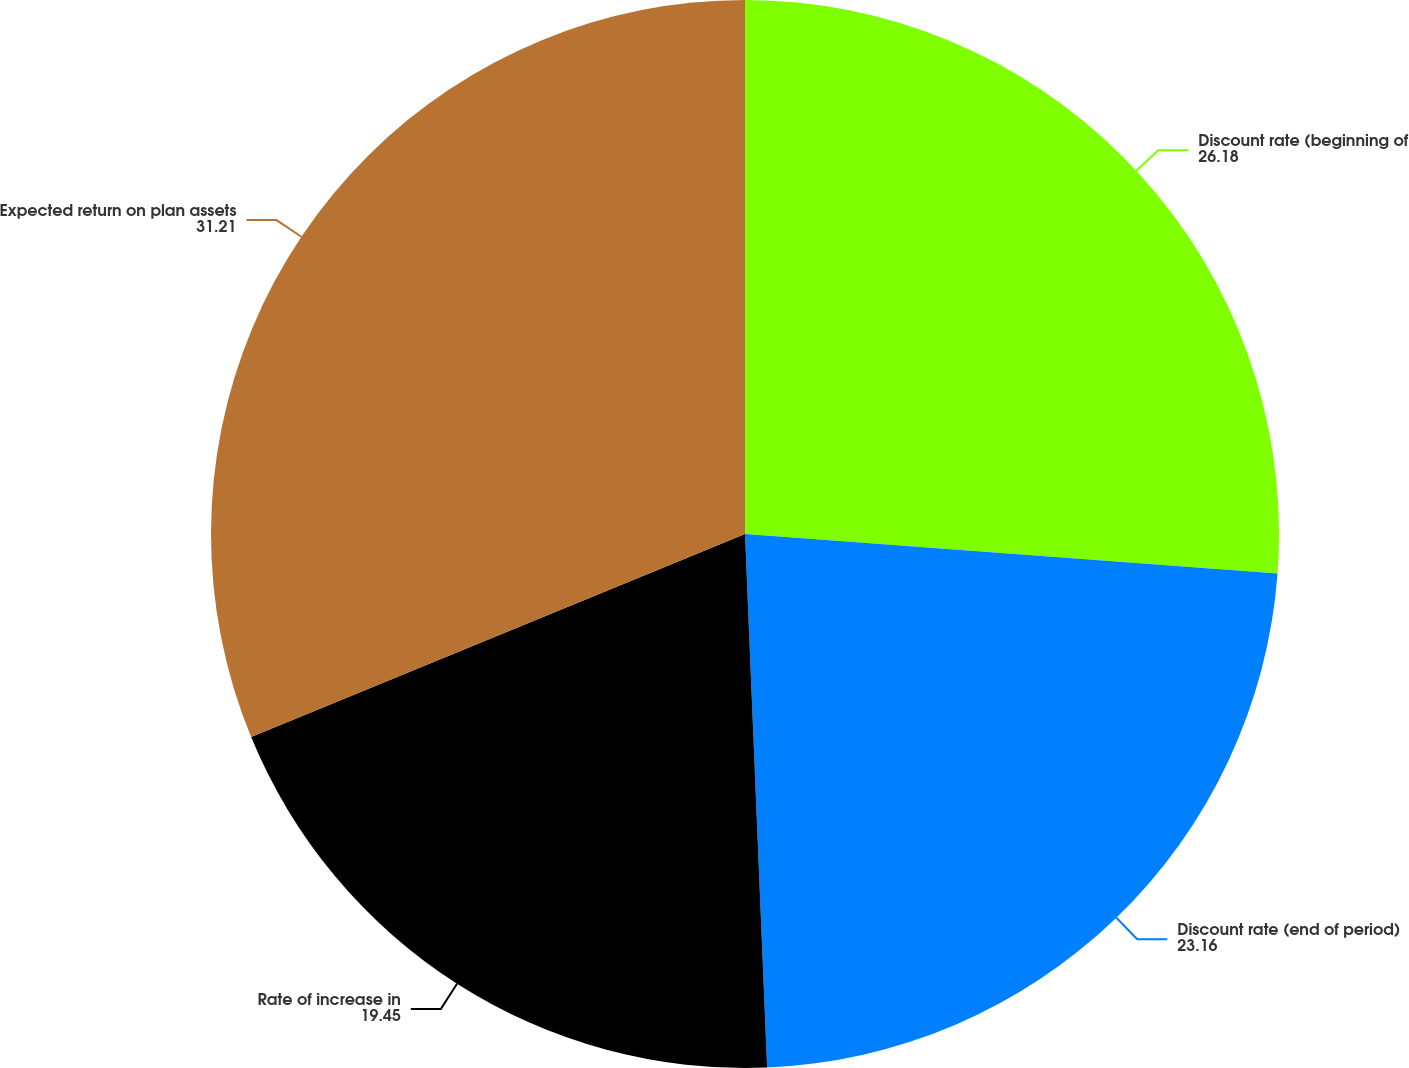Convert chart. <chart><loc_0><loc_0><loc_500><loc_500><pie_chart><fcel>Discount rate (beginning of<fcel>Discount rate (end of period)<fcel>Rate of increase in<fcel>Expected return on plan assets<nl><fcel>26.18%<fcel>23.16%<fcel>19.45%<fcel>31.21%<nl></chart> 